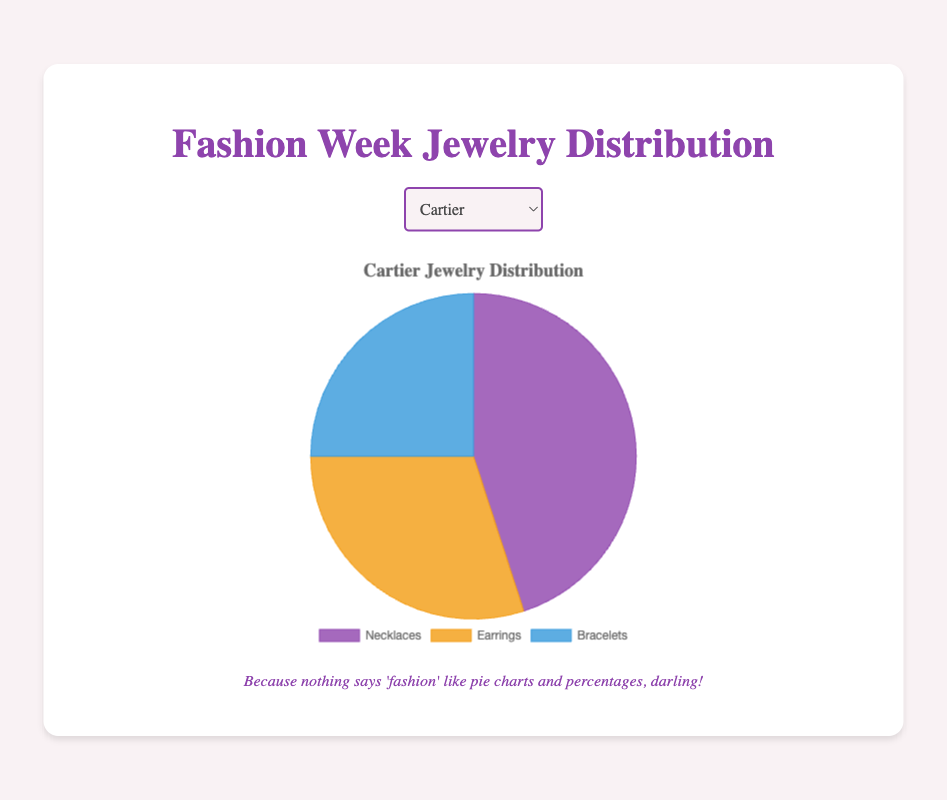Which jewelry type has the highest distribution for Cartier? Look at the slice associated with Cartier in the pie chart and identify which jewelry type occupies the largest portion. Necklaces have the largest slice.
Answer: Necklaces Which brand has the highest percentage of necklaces displayed? Compare the slices representing necklaces for each brand. The brand with the largest slice for necklaces is Chopard.
Answer: Chopard What is the total number of jewelry pieces displayed by Tiffany & Co.? Sum the number of necklaces, earrings, and bracelets for Tiffany & Co.: 40 + 35 + 25 = 100.
Answer: 100 What is the difference in the number of earrings between Cartier and Harry Winston? Subtract the number of earrings for Harry Winston from the number of earrings for Cartier: 30 - 20 = 10.
Answer: 10 Which brand has an equal distribution of earrings and bracelets? Compare the slices of earrings and bracelets for each brand. Tiffany & Co. has an equal number of earrings and bracelets (both are 25).
Answer: Tiffany & Co Which jewelry type has the smallest slice for Chopard? Look at the pie chart for Chopard and identify the smallest slice. Bracelets have the smallest slice.
Answer: Bracelets How does the distribution of bracelets compare between Cartier and Chopard? Compare the slices for bracelets between the two brands. Cartier has a larger slice for bracelets than Chopard.
Answer: Cartier has more What is the average number of earrings displayed by all brands? Sum the number of earrings for all brands and divide by the number of brands: (30 + 35 + 20 + 25)/4 = 27.5.
Answer: 27.5 